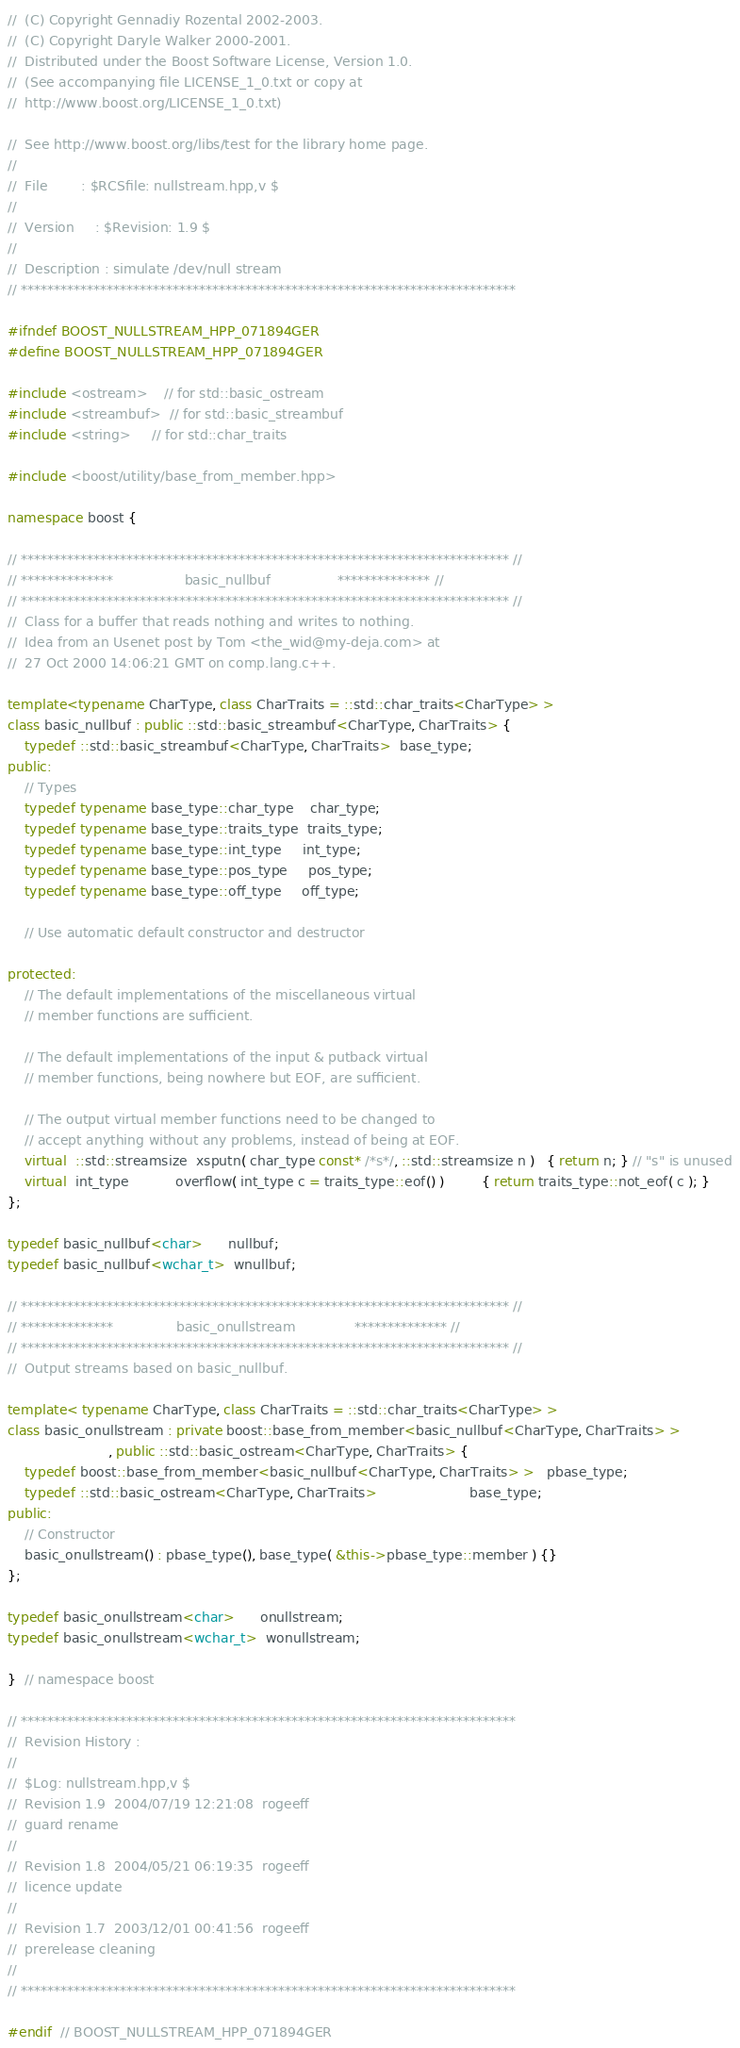<code> <loc_0><loc_0><loc_500><loc_500><_C++_>//  (C) Copyright Gennadiy Rozental 2002-2003.
//  (C) Copyright Daryle Walker 2000-2001. 
//  Distributed under the Boost Software License, Version 1.0.
//  (See accompanying file LICENSE_1_0.txt or copy at 
//  http://www.boost.org/LICENSE_1_0.txt)

//  See http://www.boost.org/libs/test for the library home page.
//
//  File        : $RCSfile: nullstream.hpp,v $
//
//  Version     : $Revision: 1.9 $
//
//  Description : simulate /dev/null stream
// ***************************************************************************

#ifndef BOOST_NULLSTREAM_HPP_071894GER
#define BOOST_NULLSTREAM_HPP_071894GER

#include <ostream>    // for std::basic_ostream
#include <streambuf>  // for std::basic_streambuf
#include <string>     // for std::char_traits

#include <boost/utility/base_from_member.hpp>

namespace boost {

// ************************************************************************** //
// **************                 basic_nullbuf                ************** //
// ************************************************************************** //
//  Class for a buffer that reads nothing and writes to nothing.
//  Idea from an Usenet post by Tom <the_wid@my-deja.com> at
//  27 Oct 2000 14:06:21 GMT on comp.lang.c++.

template<typename CharType, class CharTraits = ::std::char_traits<CharType> >
class basic_nullbuf : public ::std::basic_streambuf<CharType, CharTraits> {
    typedef ::std::basic_streambuf<CharType, CharTraits>  base_type;
public:
    // Types
    typedef typename base_type::char_type    char_type;
    typedef typename base_type::traits_type  traits_type;
    typedef typename base_type::int_type     int_type;
    typedef typename base_type::pos_type     pos_type;
    typedef typename base_type::off_type     off_type;

    // Use automatic default constructor and destructor

protected:
    // The default implementations of the miscellaneous virtual
    // member functions are sufficient.

    // The default implementations of the input & putback virtual
    // member functions, being nowhere but EOF, are sufficient.

    // The output virtual member functions need to be changed to
    // accept anything without any problems, instead of being at EOF.
    virtual  ::std::streamsize  xsputn( char_type const* /*s*/, ::std::streamsize n )   { return n; } // "s" is unused
    virtual  int_type           overflow( int_type c = traits_type::eof() )         { return traits_type::not_eof( c ); }
};

typedef basic_nullbuf<char>      nullbuf;
typedef basic_nullbuf<wchar_t>  wnullbuf;

// ************************************************************************** //
// **************               basic_onullstream              ************** //
// ************************************************************************** //
//  Output streams based on basic_nullbuf.

template< typename CharType, class CharTraits = ::std::char_traits<CharType> >
class basic_onullstream : private boost::base_from_member<basic_nullbuf<CharType, CharTraits> >
                        , public ::std::basic_ostream<CharType, CharTraits> {
    typedef boost::base_from_member<basic_nullbuf<CharType, CharTraits> >   pbase_type;
    typedef ::std::basic_ostream<CharType, CharTraits>                      base_type;
public:
    // Constructor
    basic_onullstream() : pbase_type(), base_type( &this->pbase_type::member ) {}
};

typedef basic_onullstream<char>      onullstream;
typedef basic_onullstream<wchar_t>  wonullstream;

}  // namespace boost

// ***************************************************************************
//  Revision History :
//  
//  $Log: nullstream.hpp,v $
//  Revision 1.9  2004/07/19 12:21:08  rogeeff
//  guard rename
//
//  Revision 1.8  2004/05/21 06:19:35  rogeeff
//  licence update
//
//  Revision 1.7  2003/12/01 00:41:56  rogeeff
//  prerelease cleaning
//
// ***************************************************************************

#endif  // BOOST_NULLSTREAM_HPP_071894GER
</code> 